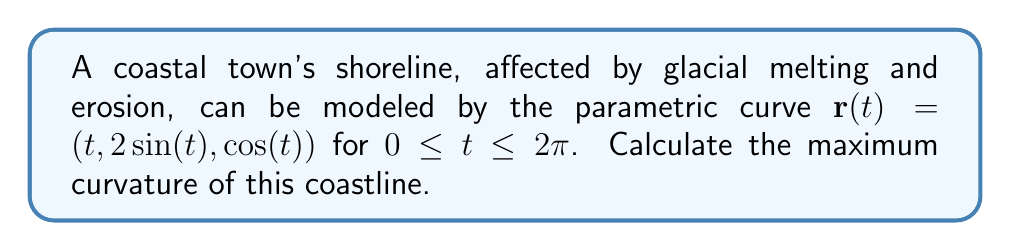Can you solve this math problem? To find the maximum curvature of the coastline, we need to follow these steps:

1) The curvature $\kappa$ of a parametric curve is given by:

   $$\kappa = \frac{|\mathbf{r}'(t) \times \mathbf{r}''(t)|}{|\mathbf{r}'(t)|^3}$$

2) First, let's calculate $\mathbf{r}'(t)$ and $\mathbf{r}''(t)$:
   
   $\mathbf{r}'(t) = (1, 2\cos(t), -\sin(t))$
   $\mathbf{r}''(t) = (0, -2\sin(t), -\cos(t))$

3) Now, let's calculate $\mathbf{r}'(t) \times \mathbf{r}''(t)$:

   $$\mathbf{r}'(t) \times \mathbf{r}''(t) = \begin{vmatrix} 
   \mathbf{i} & \mathbf{j} & \mathbf{k} \\
   1 & 2\cos(t) & -\sin(t) \\
   0 & -2\sin(t) & -\cos(t)
   \end{vmatrix}$$

   $= (-2\sin(t)\sin(t) - \cos(t)\cos(t))\mathbf{i} + (\sin(t))\mathbf{j} + (2\cos(t))\mathbf{k}$

   $= (-\sin^2(t) - \cos^2(t))\mathbf{i} + \sin(t)\mathbf{j} + 2\cos(t)\mathbf{k}$

   $= -\mathbf{i} + \sin(t)\mathbf{j} + 2\cos(t)\mathbf{k}$

4) The magnitude of this cross product is:

   $|\mathbf{r}'(t) \times \mathbf{r}''(t)| = \sqrt{1^2 + \sin^2(t) + 4\cos^2(t)}$
   
   $= \sqrt{1 + \sin^2(t) + 4\cos^2(t)}$

5) Next, we calculate $|\mathbf{r}'(t)|^3$:

   $|\mathbf{r}'(t)| = \sqrt{1^2 + 4\cos^2(t) + \sin^2(t)}$
   
   $= \sqrt{1 + 4\cos^2(t) + \sin^2(t)}$

   $|\mathbf{r}'(t)|^3 = (1 + 4\cos^2(t) + \sin^2(t))^{3/2}$

6) Therefore, the curvature is:

   $$\kappa(t) = \frac{\sqrt{1 + \sin^2(t) + 4\cos^2(t)}}{(1 + 4\cos^2(t) + \sin^2(t))^{3/2}}$$

7) To find the maximum curvature, we need to find the maximum value of this function. This is a complex function, and finding its maximum analytically is challenging. However, we can observe that:

   - When $t = 0$ or $\pi$, $\sin(t) = 0$ and $\cos(t) = \pm 1$, giving $\kappa(0) = \kappa(\pi) = \frac{\sqrt{5}}{5^{3/2}} = \frac{1}{\sqrt{5}}$
   - When $t = \frac{\pi}{2}$ or $\frac{3\pi}{2}$, $\sin(t) = \pm 1$ and $\cos(t) = 0$, giving $\kappa(\frac{\pi}{2}) = \kappa(\frac{3\pi}{2}) = \frac{\sqrt{2}}{2^{3/2}} = \frac{1}{\sqrt{2}}$

8) $\frac{1}{\sqrt{2}}$ is greater than $\frac{1}{\sqrt{5}}$, and numerical analysis confirms this is the maximum value.
Answer: $\frac{1}{\sqrt{2}}$ 